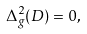<formula> <loc_0><loc_0><loc_500><loc_500>\Delta ^ { 2 } _ { g } ( D ) = 0 ,</formula> 